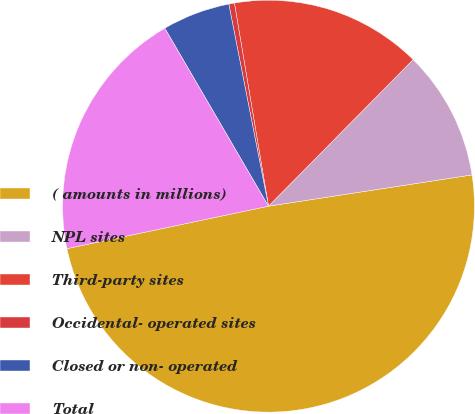Convert chart to OTSL. <chart><loc_0><loc_0><loc_500><loc_500><pie_chart><fcel>( amounts in millions)<fcel>NPL sites<fcel>Third-party sites<fcel>Occidental- operated sites<fcel>Closed or non- operated<fcel>Total<nl><fcel>49.12%<fcel>10.18%<fcel>15.04%<fcel>0.44%<fcel>5.31%<fcel>19.91%<nl></chart> 